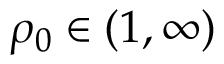<formula> <loc_0><loc_0><loc_500><loc_500>\rho _ { 0 } \in ( 1 , \infty )</formula> 